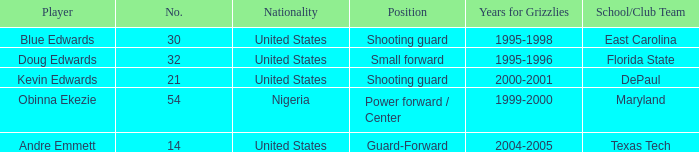Which school/club team did blue edwards play for East Carolina. 